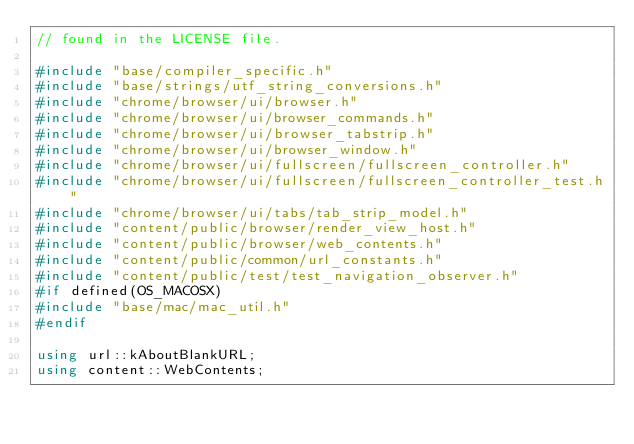<code> <loc_0><loc_0><loc_500><loc_500><_C++_>// found in the LICENSE file.

#include "base/compiler_specific.h"
#include "base/strings/utf_string_conversions.h"
#include "chrome/browser/ui/browser.h"
#include "chrome/browser/ui/browser_commands.h"
#include "chrome/browser/ui/browser_tabstrip.h"
#include "chrome/browser/ui/browser_window.h"
#include "chrome/browser/ui/fullscreen/fullscreen_controller.h"
#include "chrome/browser/ui/fullscreen/fullscreen_controller_test.h"
#include "chrome/browser/ui/tabs/tab_strip_model.h"
#include "content/public/browser/render_view_host.h"
#include "content/public/browser/web_contents.h"
#include "content/public/common/url_constants.h"
#include "content/public/test/test_navigation_observer.h"
#if defined(OS_MACOSX)
#include "base/mac/mac_util.h"
#endif

using url::kAboutBlankURL;
using content::WebContents;</code> 